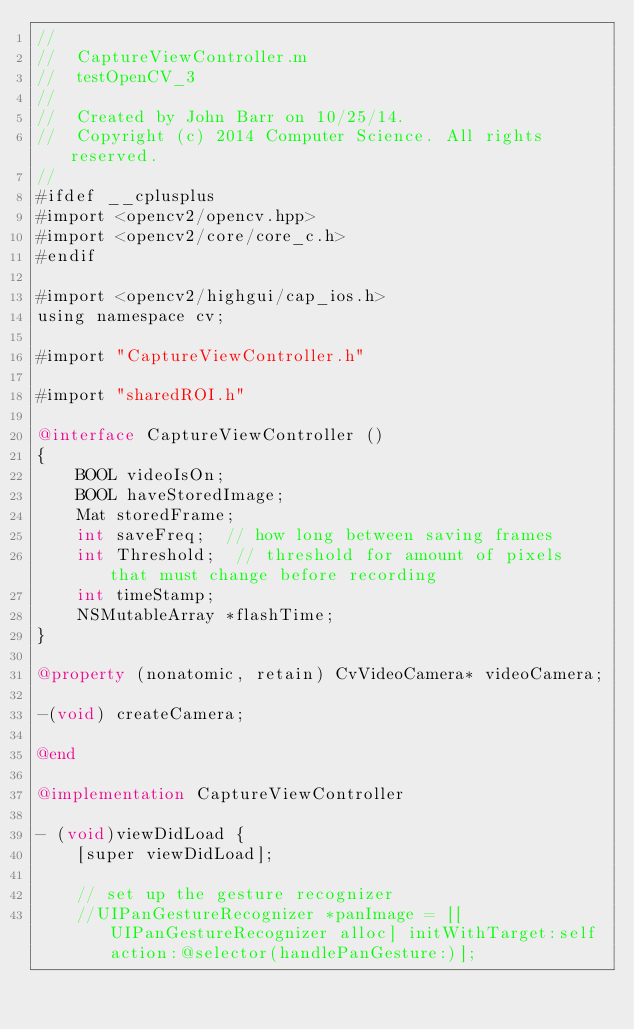Convert code to text. <code><loc_0><loc_0><loc_500><loc_500><_ObjectiveC_>//
//  CaptureViewController.m
//  testOpenCV_3
//
//  Created by John Barr on 10/25/14.
//  Copyright (c) 2014 Computer Science. All rights reserved.
//
#ifdef __cplusplus
#import <opencv2/opencv.hpp>
#import <opencv2/core/core_c.h>
#endif

#import <opencv2/highgui/cap_ios.h>
using namespace cv;

#import "CaptureViewController.h"

#import "sharedROI.h"

@interface CaptureViewController ()
{
    BOOL videoIsOn;
    BOOL haveStoredImage;
    Mat storedFrame;
    int saveFreq;  // how long between saving frames
    int Threshold;  // threshold for amount of pixels that must change before recording
    int timeStamp;
    NSMutableArray *flashTime;
}

@property (nonatomic, retain) CvVideoCamera* videoCamera;

-(void) createCamera;

@end

@implementation CaptureViewController

- (void)viewDidLoad {
    [super viewDidLoad];
        
    // set up the gesture recognizer
    //UIPanGestureRecognizer *panImage = [[UIPanGestureRecognizer alloc] initWithTarget:self action:@selector(handlePanGesture:)];</code> 